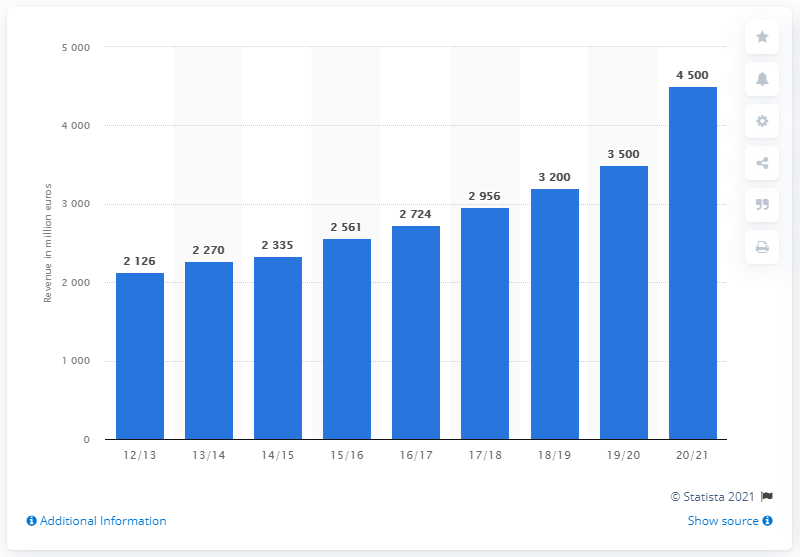Identify some key points in this picture. The previous year's revenue for OTTO in e-commerce was approximately 3500. In the 2020/21 financial year, OTTO's revenue in e-commerce was approximately 4,500. 